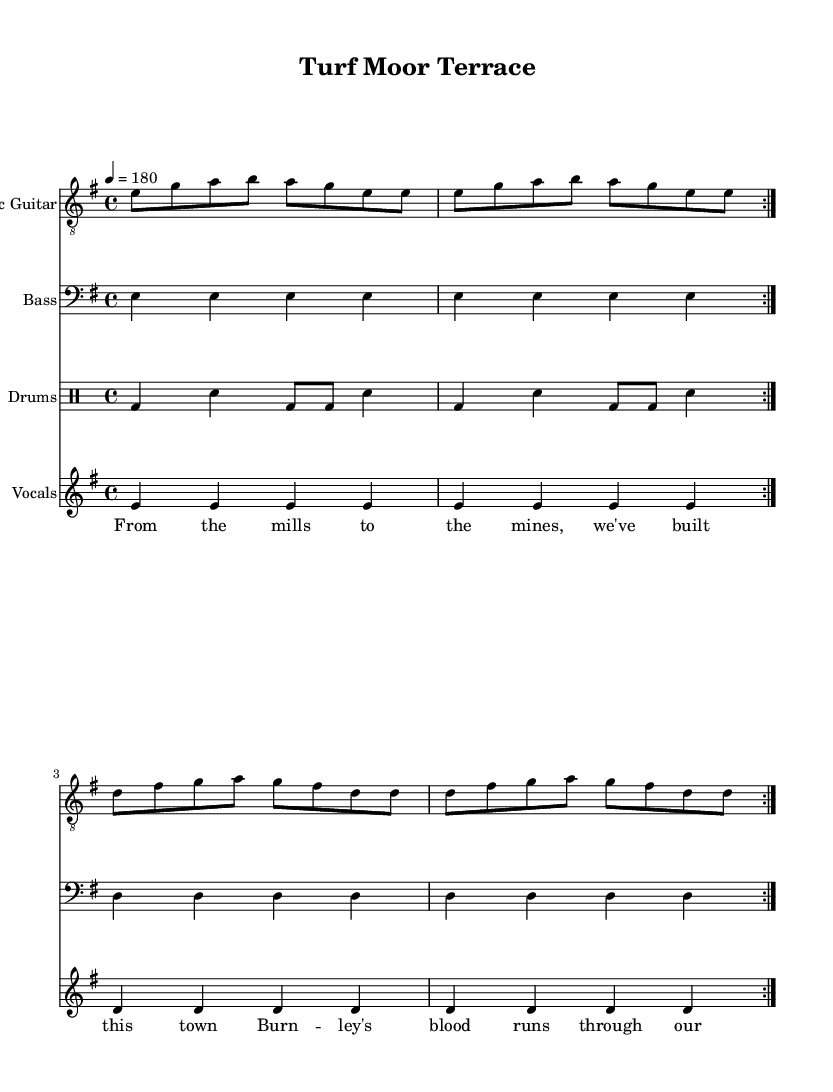What is the key signature of this music? The key signature is E minor, as indicated by the presence of one sharp (F#) at the beginning of the staff.
Answer: E minor What is the time signature of this music? The time signature is 4/4, which means there are four beats in each measure and the quarter note receives one beat. This is indicated in the notation above the staff.
Answer: 4/4 What is the tempo marking for this piece? The tempo marking is 180 beats per minute, as shown by the "4 = 180" indication in the score. This means the quarter note should be played at a rapid pace of 180 beats.
Answer: 180 How many repetitions of the "electric guitar" section are indicated? The music shows "repeat volta 2," meaning that the section for electric guitar should be played two times. This is specified near the start of the melody section for the guitar.
Answer: 2 What is the main theme of the lyrics? The lyrics reflect a working-class pride and identity tied to Burnley, as articulated in lines that mention mills, mines, and town building. The theme revolves around local heritage and communal strength.
Answer: Working-class pride What type of rhythm do the drums employ? The drum part utilizes a standard punk rhythm, featuring a consistent bass drum and snare pattern that supports the fast-paced tempo typical of the genre. This is evident in the repeated measures and strong backbeat.
Answer: Punk rhythm What instrument plays the melody? The electric guitar plays the melody in this score as indicated at the beginning of the staff where the instrument name is listed.
Answer: Electric Guitar 